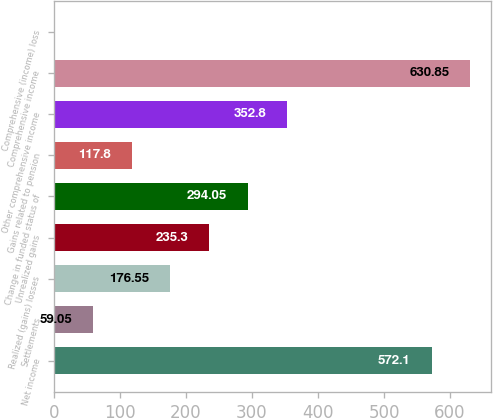Convert chart. <chart><loc_0><loc_0><loc_500><loc_500><bar_chart><fcel>Net income<fcel>Settlements<fcel>Realized (gains) losses<fcel>Unrealized gains<fcel>Change in funded status of<fcel>Gains related to pension<fcel>Other comprehensive income<fcel>Comprehensive income<fcel>Comprehensive (income) loss<nl><fcel>572.1<fcel>59.05<fcel>176.55<fcel>235.3<fcel>294.05<fcel>117.8<fcel>352.8<fcel>630.85<fcel>0.3<nl></chart> 